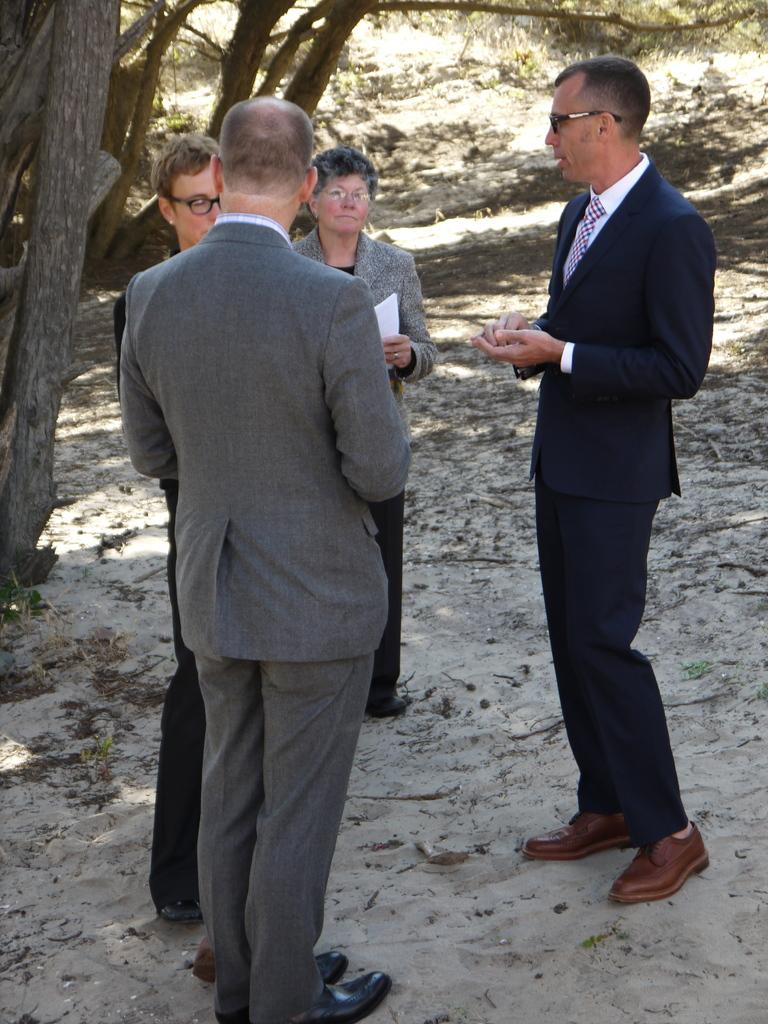What can be seen in the image involving people? There are people standing in the image. What are the people wearing? The people are wearing clothes and shoes. Are there any accessories visible on the people? Some people are wearing spectacles. What can be seen in the image related to nature? There are sad, dry leaves and tree branches in the image. How does the guitar contribute to the image? There is no guitar present in the image. What is the effect of the earthquake on the people in the image? There is no mention of an earthquake in the image or the provided facts. 